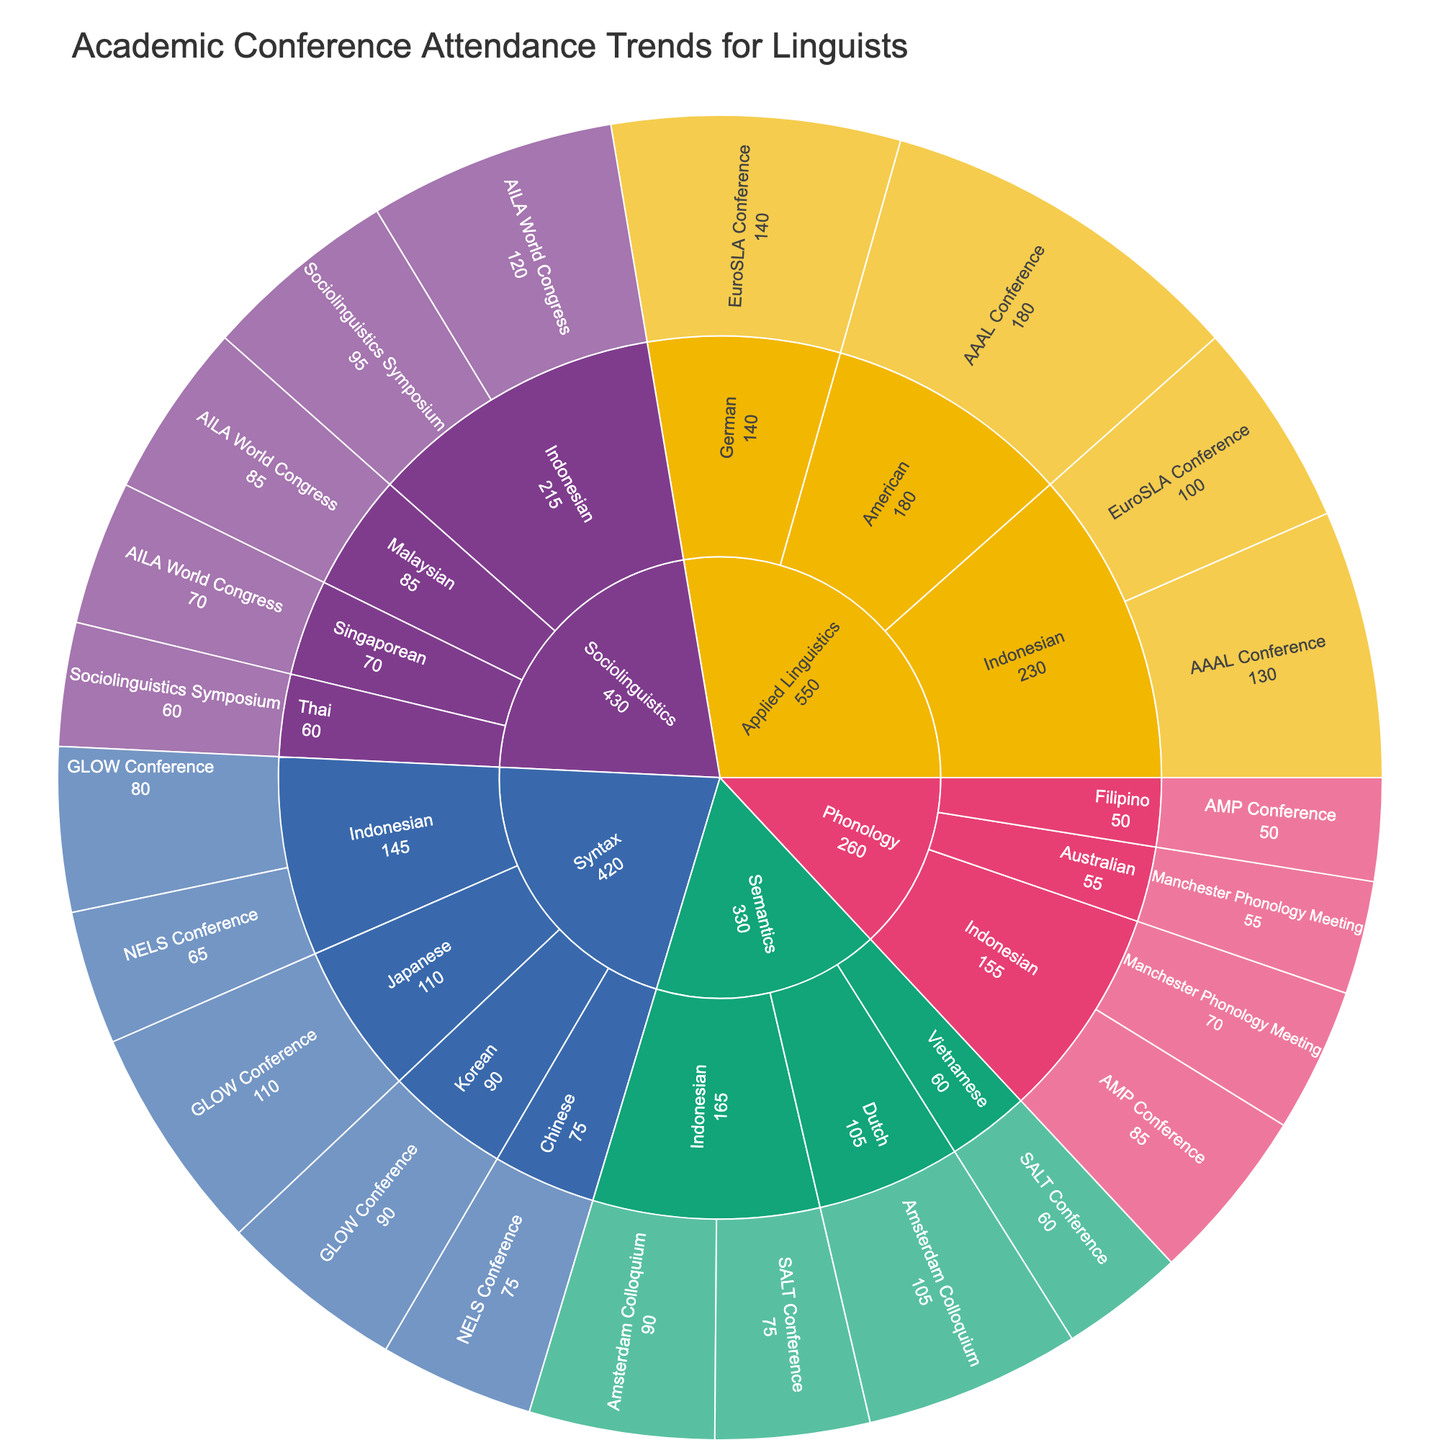How many themes are displayed in the Sunburst Plot? First, locate the outermost ring of the Sunburst Plot, which represents the "themes". Each segment in this ring corresponds to a different theme.
Answer: 5 Which nationality has the highest attendance in the AAAL Conference? Find the segment corresponding to the AAAL Conference under the "Applied Linguistics" theme. Then, check the segments for nationalities within this conference. The one with the largest value will have the highest attendance.
Answer: American How many Indonesian attendees are there across all conferences? Locate all segments labeled "Indonesian" across different themes and conferences. Sum the values of attendees in each of these segments.
Answer: 730 Which conference has more attendees from Indonesian linguists, the GLOW Conference or the NELS Conference? Identify the segments for the GLOW Conference and the NELS Conference under the Syntax theme. Compare the attendee counts for the Indonesian nationality within these segments.
Answer: GLOW Conference What is the total attendance for conferences under the "Phonology" theme? Identify all segments under the "Phonology" theme, then sum the attendee counts for each conference within this theme.
Answer: 260 Is the attendance of Malaysian linguists at the AILA World Congress greater than the attendance of Indonesian linguists at the Sociolinguistics Symposium? Compare the attendee count for Malaysian linguists at the AILA World Congress with that of Indonesian linguists at the Sociolinguistics Symposium.
Answer: No Which nationality dominates attendance in the Semantics theme? Look for the nationality segments under the Semantics theme and compare their attendee counts. The nationality with the highest count dominates.
Answer: Dutch What is the percentage of attendees from the AILA World Congress compared to the total attendees of all conferences? First, find the total number of attendees for the AILA World Congress. Then, sum the total number of attendees for all the displayed conferences. Calculate the percentage by dividing the AILA World Congress attendees by the total attendees and multiplying by 100.
Answer: 23.5% In which theme do Indonesian linguists have the lowest attendance? Find all the segments representing Indonesian linguists across all themes and identify the one with the smallest value.
Answer: Syntax Are there more attendees from the Netherlands at the Amsterdam Colloquium than Vietnamese attendees at the SALT Conference? Locate the segments for the Amsterdam Colloquium under Semantics and the SALT Conference under the same theme. Compare the attendee counts for the Dutch and Vietnamese nationalities.
Answer: Yes 